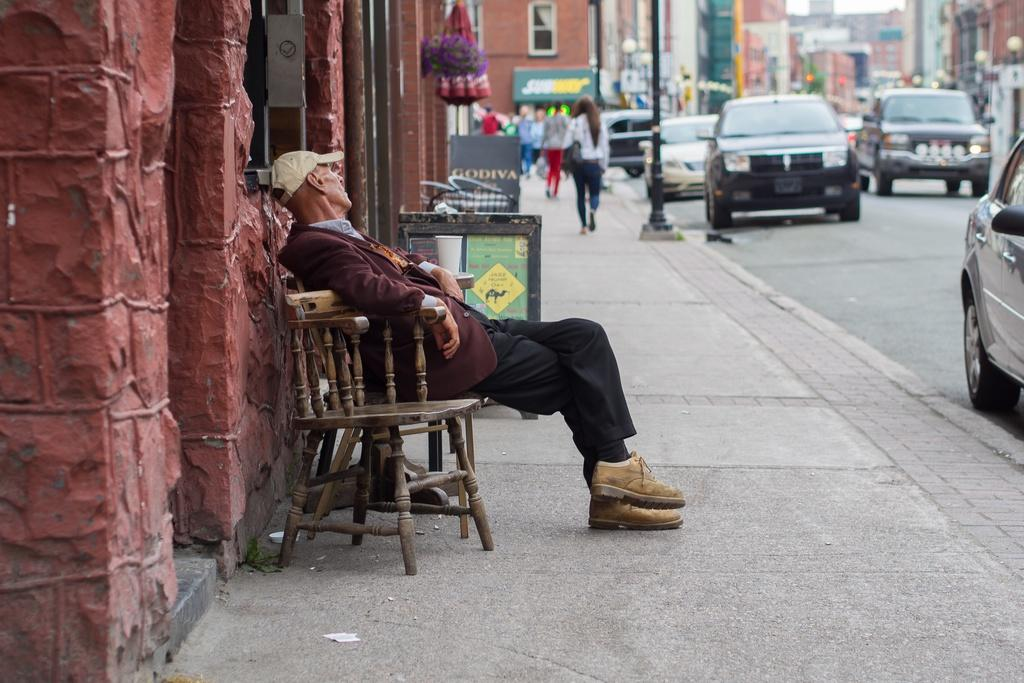What is the person in the image doing? There is a person sitting on a chair in the image. What else can be seen in the image besides the person? There are vehicles, people walking on the sidewalk, buildings, the sky, and a banner visible in the image. Can you describe the vehicles in the image? The provided facts do not specify the type or number of vehicles in the image. What is the background of the image like? The background of the image includes people walking on the sidewalk, buildings, the sky, and a banner. How much dust is visible on the star in the image? There is no star or dust present in the image. What is the person in the image in need of? The provided facts do not indicate any specific need or requirement for the person in the image. 